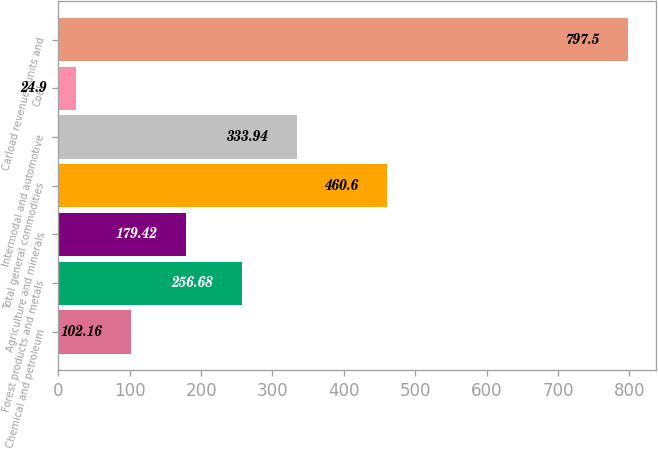Convert chart. <chart><loc_0><loc_0><loc_500><loc_500><bar_chart><fcel>Chemical and petroleum<fcel>Forest products and metals<fcel>Agriculture and minerals<fcel>Total general commodities<fcel>Intermodal and automotive<fcel>Coal<fcel>Carload revenues units and<nl><fcel>102.16<fcel>256.68<fcel>179.42<fcel>460.6<fcel>333.94<fcel>24.9<fcel>797.5<nl></chart> 